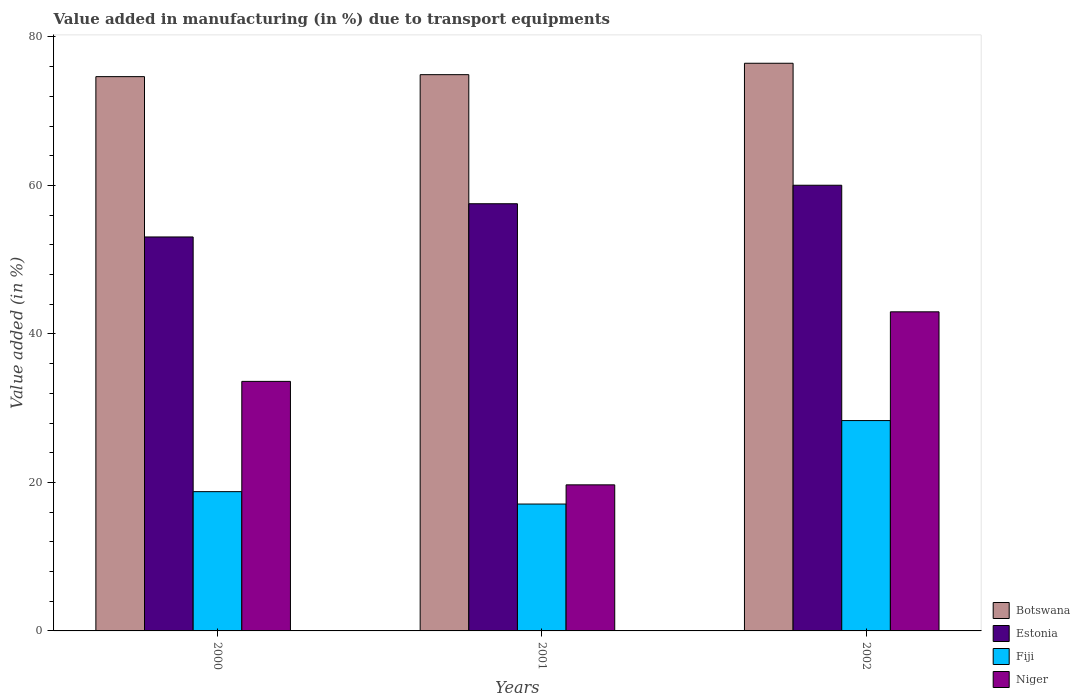Are the number of bars per tick equal to the number of legend labels?
Offer a very short reply. Yes. Are the number of bars on each tick of the X-axis equal?
Your answer should be compact. Yes. How many bars are there on the 3rd tick from the left?
Keep it short and to the point. 4. How many bars are there on the 3rd tick from the right?
Your answer should be very brief. 4. What is the label of the 3rd group of bars from the left?
Offer a terse response. 2002. What is the percentage of value added in manufacturing due to transport equipments in Fiji in 2002?
Your answer should be very brief. 28.33. Across all years, what is the maximum percentage of value added in manufacturing due to transport equipments in Niger?
Make the answer very short. 42.98. Across all years, what is the minimum percentage of value added in manufacturing due to transport equipments in Fiji?
Ensure brevity in your answer.  17.09. In which year was the percentage of value added in manufacturing due to transport equipments in Fiji minimum?
Ensure brevity in your answer.  2001. What is the total percentage of value added in manufacturing due to transport equipments in Botswana in the graph?
Ensure brevity in your answer.  226.04. What is the difference between the percentage of value added in manufacturing due to transport equipments in Estonia in 2001 and that in 2002?
Keep it short and to the point. -2.49. What is the difference between the percentage of value added in manufacturing due to transport equipments in Botswana in 2000 and the percentage of value added in manufacturing due to transport equipments in Estonia in 2001?
Your answer should be compact. 17.12. What is the average percentage of value added in manufacturing due to transport equipments in Botswana per year?
Make the answer very short. 75.35. In the year 2002, what is the difference between the percentage of value added in manufacturing due to transport equipments in Niger and percentage of value added in manufacturing due to transport equipments in Botswana?
Provide a short and direct response. -33.48. What is the ratio of the percentage of value added in manufacturing due to transport equipments in Fiji in 2001 to that in 2002?
Make the answer very short. 0.6. Is the percentage of value added in manufacturing due to transport equipments in Estonia in 2000 less than that in 2002?
Your answer should be very brief. Yes. What is the difference between the highest and the second highest percentage of value added in manufacturing due to transport equipments in Estonia?
Your answer should be compact. 2.49. What is the difference between the highest and the lowest percentage of value added in manufacturing due to transport equipments in Estonia?
Make the answer very short. 6.97. In how many years, is the percentage of value added in manufacturing due to transport equipments in Botswana greater than the average percentage of value added in manufacturing due to transport equipments in Botswana taken over all years?
Provide a short and direct response. 1. What does the 3rd bar from the left in 2000 represents?
Provide a short and direct response. Fiji. What does the 3rd bar from the right in 2002 represents?
Offer a very short reply. Estonia. Is it the case that in every year, the sum of the percentage of value added in manufacturing due to transport equipments in Niger and percentage of value added in manufacturing due to transport equipments in Botswana is greater than the percentage of value added in manufacturing due to transport equipments in Estonia?
Your answer should be compact. Yes. How many bars are there?
Ensure brevity in your answer.  12. Are all the bars in the graph horizontal?
Keep it short and to the point. No. Are the values on the major ticks of Y-axis written in scientific E-notation?
Provide a short and direct response. No. Where does the legend appear in the graph?
Keep it short and to the point. Bottom right. How many legend labels are there?
Offer a very short reply. 4. How are the legend labels stacked?
Provide a short and direct response. Vertical. What is the title of the graph?
Your response must be concise. Value added in manufacturing (in %) due to transport equipments. Does "Uruguay" appear as one of the legend labels in the graph?
Your response must be concise. No. What is the label or title of the Y-axis?
Keep it short and to the point. Value added (in %). What is the Value added (in %) in Botswana in 2000?
Ensure brevity in your answer.  74.66. What is the Value added (in %) in Estonia in 2000?
Give a very brief answer. 53.06. What is the Value added (in %) of Fiji in 2000?
Keep it short and to the point. 18.76. What is the Value added (in %) in Niger in 2000?
Your response must be concise. 33.61. What is the Value added (in %) of Botswana in 2001?
Give a very brief answer. 74.92. What is the Value added (in %) in Estonia in 2001?
Ensure brevity in your answer.  57.54. What is the Value added (in %) in Fiji in 2001?
Offer a terse response. 17.09. What is the Value added (in %) of Niger in 2001?
Offer a very short reply. 19.67. What is the Value added (in %) of Botswana in 2002?
Provide a short and direct response. 76.46. What is the Value added (in %) of Estonia in 2002?
Provide a succinct answer. 60.03. What is the Value added (in %) of Fiji in 2002?
Provide a short and direct response. 28.33. What is the Value added (in %) of Niger in 2002?
Your answer should be very brief. 42.98. Across all years, what is the maximum Value added (in %) of Botswana?
Ensure brevity in your answer.  76.46. Across all years, what is the maximum Value added (in %) of Estonia?
Offer a very short reply. 60.03. Across all years, what is the maximum Value added (in %) in Fiji?
Provide a short and direct response. 28.33. Across all years, what is the maximum Value added (in %) of Niger?
Offer a terse response. 42.98. Across all years, what is the minimum Value added (in %) of Botswana?
Ensure brevity in your answer.  74.66. Across all years, what is the minimum Value added (in %) of Estonia?
Offer a very short reply. 53.06. Across all years, what is the minimum Value added (in %) of Fiji?
Your answer should be very brief. 17.09. Across all years, what is the minimum Value added (in %) of Niger?
Your answer should be compact. 19.67. What is the total Value added (in %) in Botswana in the graph?
Ensure brevity in your answer.  226.04. What is the total Value added (in %) of Estonia in the graph?
Keep it short and to the point. 170.63. What is the total Value added (in %) of Fiji in the graph?
Give a very brief answer. 64.18. What is the total Value added (in %) of Niger in the graph?
Ensure brevity in your answer.  96.27. What is the difference between the Value added (in %) of Botswana in 2000 and that in 2001?
Offer a very short reply. -0.26. What is the difference between the Value added (in %) in Estonia in 2000 and that in 2001?
Provide a succinct answer. -4.47. What is the difference between the Value added (in %) of Fiji in 2000 and that in 2001?
Ensure brevity in your answer.  1.67. What is the difference between the Value added (in %) of Niger in 2000 and that in 2001?
Make the answer very short. 13.94. What is the difference between the Value added (in %) of Botswana in 2000 and that in 2002?
Keep it short and to the point. -1.8. What is the difference between the Value added (in %) in Estonia in 2000 and that in 2002?
Keep it short and to the point. -6.97. What is the difference between the Value added (in %) in Fiji in 2000 and that in 2002?
Offer a very short reply. -9.57. What is the difference between the Value added (in %) in Niger in 2000 and that in 2002?
Offer a very short reply. -9.37. What is the difference between the Value added (in %) of Botswana in 2001 and that in 2002?
Ensure brevity in your answer.  -1.54. What is the difference between the Value added (in %) in Estonia in 2001 and that in 2002?
Keep it short and to the point. -2.49. What is the difference between the Value added (in %) of Fiji in 2001 and that in 2002?
Offer a terse response. -11.24. What is the difference between the Value added (in %) in Niger in 2001 and that in 2002?
Make the answer very short. -23.31. What is the difference between the Value added (in %) in Botswana in 2000 and the Value added (in %) in Estonia in 2001?
Your response must be concise. 17.12. What is the difference between the Value added (in %) of Botswana in 2000 and the Value added (in %) of Fiji in 2001?
Ensure brevity in your answer.  57.57. What is the difference between the Value added (in %) of Botswana in 2000 and the Value added (in %) of Niger in 2001?
Provide a succinct answer. 54.98. What is the difference between the Value added (in %) of Estonia in 2000 and the Value added (in %) of Fiji in 2001?
Your answer should be compact. 35.97. What is the difference between the Value added (in %) in Estonia in 2000 and the Value added (in %) in Niger in 2001?
Offer a terse response. 33.39. What is the difference between the Value added (in %) of Fiji in 2000 and the Value added (in %) of Niger in 2001?
Provide a succinct answer. -0.91. What is the difference between the Value added (in %) of Botswana in 2000 and the Value added (in %) of Estonia in 2002?
Offer a terse response. 14.63. What is the difference between the Value added (in %) in Botswana in 2000 and the Value added (in %) in Fiji in 2002?
Ensure brevity in your answer.  46.33. What is the difference between the Value added (in %) of Botswana in 2000 and the Value added (in %) of Niger in 2002?
Keep it short and to the point. 31.68. What is the difference between the Value added (in %) of Estonia in 2000 and the Value added (in %) of Fiji in 2002?
Provide a succinct answer. 24.73. What is the difference between the Value added (in %) in Estonia in 2000 and the Value added (in %) in Niger in 2002?
Give a very brief answer. 10.08. What is the difference between the Value added (in %) in Fiji in 2000 and the Value added (in %) in Niger in 2002?
Your response must be concise. -24.22. What is the difference between the Value added (in %) in Botswana in 2001 and the Value added (in %) in Estonia in 2002?
Keep it short and to the point. 14.89. What is the difference between the Value added (in %) in Botswana in 2001 and the Value added (in %) in Fiji in 2002?
Give a very brief answer. 46.59. What is the difference between the Value added (in %) of Botswana in 2001 and the Value added (in %) of Niger in 2002?
Make the answer very short. 31.94. What is the difference between the Value added (in %) in Estonia in 2001 and the Value added (in %) in Fiji in 2002?
Your answer should be compact. 29.2. What is the difference between the Value added (in %) of Estonia in 2001 and the Value added (in %) of Niger in 2002?
Your response must be concise. 14.56. What is the difference between the Value added (in %) in Fiji in 2001 and the Value added (in %) in Niger in 2002?
Keep it short and to the point. -25.89. What is the average Value added (in %) of Botswana per year?
Provide a succinct answer. 75.35. What is the average Value added (in %) of Estonia per year?
Ensure brevity in your answer.  56.88. What is the average Value added (in %) in Fiji per year?
Ensure brevity in your answer.  21.39. What is the average Value added (in %) of Niger per year?
Your answer should be very brief. 32.09. In the year 2000, what is the difference between the Value added (in %) in Botswana and Value added (in %) in Estonia?
Offer a terse response. 21.6. In the year 2000, what is the difference between the Value added (in %) in Botswana and Value added (in %) in Fiji?
Your response must be concise. 55.9. In the year 2000, what is the difference between the Value added (in %) in Botswana and Value added (in %) in Niger?
Offer a terse response. 41.05. In the year 2000, what is the difference between the Value added (in %) in Estonia and Value added (in %) in Fiji?
Keep it short and to the point. 34.3. In the year 2000, what is the difference between the Value added (in %) of Estonia and Value added (in %) of Niger?
Provide a short and direct response. 19.45. In the year 2000, what is the difference between the Value added (in %) in Fiji and Value added (in %) in Niger?
Provide a short and direct response. -14.85. In the year 2001, what is the difference between the Value added (in %) in Botswana and Value added (in %) in Estonia?
Ensure brevity in your answer.  17.39. In the year 2001, what is the difference between the Value added (in %) of Botswana and Value added (in %) of Fiji?
Your answer should be compact. 57.83. In the year 2001, what is the difference between the Value added (in %) of Botswana and Value added (in %) of Niger?
Offer a very short reply. 55.25. In the year 2001, what is the difference between the Value added (in %) in Estonia and Value added (in %) in Fiji?
Provide a short and direct response. 40.45. In the year 2001, what is the difference between the Value added (in %) of Estonia and Value added (in %) of Niger?
Provide a short and direct response. 37.86. In the year 2001, what is the difference between the Value added (in %) of Fiji and Value added (in %) of Niger?
Give a very brief answer. -2.58. In the year 2002, what is the difference between the Value added (in %) of Botswana and Value added (in %) of Estonia?
Make the answer very short. 16.43. In the year 2002, what is the difference between the Value added (in %) of Botswana and Value added (in %) of Fiji?
Provide a succinct answer. 48.13. In the year 2002, what is the difference between the Value added (in %) in Botswana and Value added (in %) in Niger?
Offer a terse response. 33.48. In the year 2002, what is the difference between the Value added (in %) of Estonia and Value added (in %) of Fiji?
Provide a succinct answer. 31.7. In the year 2002, what is the difference between the Value added (in %) of Estonia and Value added (in %) of Niger?
Your answer should be very brief. 17.05. In the year 2002, what is the difference between the Value added (in %) of Fiji and Value added (in %) of Niger?
Offer a terse response. -14.65. What is the ratio of the Value added (in %) of Botswana in 2000 to that in 2001?
Provide a succinct answer. 1. What is the ratio of the Value added (in %) of Estonia in 2000 to that in 2001?
Your answer should be compact. 0.92. What is the ratio of the Value added (in %) in Fiji in 2000 to that in 2001?
Offer a terse response. 1.1. What is the ratio of the Value added (in %) in Niger in 2000 to that in 2001?
Keep it short and to the point. 1.71. What is the ratio of the Value added (in %) in Botswana in 2000 to that in 2002?
Your response must be concise. 0.98. What is the ratio of the Value added (in %) of Estonia in 2000 to that in 2002?
Keep it short and to the point. 0.88. What is the ratio of the Value added (in %) of Fiji in 2000 to that in 2002?
Provide a succinct answer. 0.66. What is the ratio of the Value added (in %) in Niger in 2000 to that in 2002?
Provide a succinct answer. 0.78. What is the ratio of the Value added (in %) in Botswana in 2001 to that in 2002?
Provide a short and direct response. 0.98. What is the ratio of the Value added (in %) in Estonia in 2001 to that in 2002?
Provide a short and direct response. 0.96. What is the ratio of the Value added (in %) of Fiji in 2001 to that in 2002?
Your response must be concise. 0.6. What is the ratio of the Value added (in %) of Niger in 2001 to that in 2002?
Offer a terse response. 0.46. What is the difference between the highest and the second highest Value added (in %) in Botswana?
Offer a very short reply. 1.54. What is the difference between the highest and the second highest Value added (in %) of Estonia?
Provide a short and direct response. 2.49. What is the difference between the highest and the second highest Value added (in %) of Fiji?
Make the answer very short. 9.57. What is the difference between the highest and the second highest Value added (in %) of Niger?
Give a very brief answer. 9.37. What is the difference between the highest and the lowest Value added (in %) in Botswana?
Your answer should be compact. 1.8. What is the difference between the highest and the lowest Value added (in %) in Estonia?
Offer a very short reply. 6.97. What is the difference between the highest and the lowest Value added (in %) of Fiji?
Your answer should be very brief. 11.24. What is the difference between the highest and the lowest Value added (in %) in Niger?
Give a very brief answer. 23.31. 